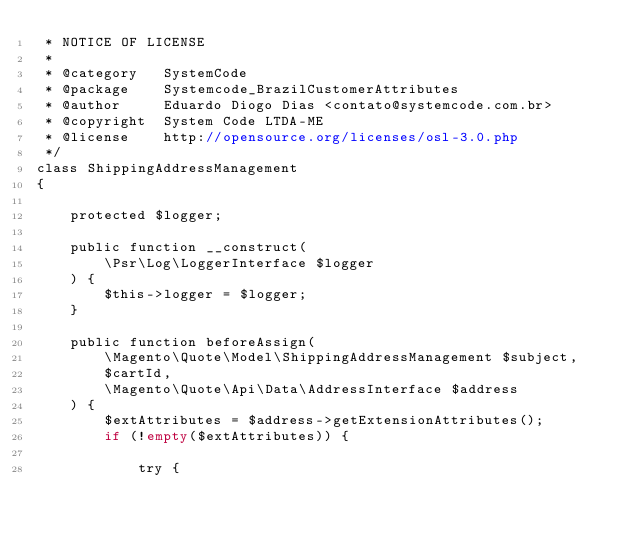<code> <loc_0><loc_0><loc_500><loc_500><_PHP_> * NOTICE OF LICENSE
 *
 * @category   SystemCode
 * @package    Systemcode_BrazilCustomerAttributes
 * @author     Eduardo Diogo Dias <contato@systemcode.com.br>
 * @copyright  System Code LTDA-ME
 * @license    http://opensource.org/licenses/osl-3.0.php
 */
class ShippingAddressManagement
{

    protected $logger;

    public function __construct(
        \Psr\Log\LoggerInterface $logger
    ) {
        $this->logger = $logger;
    }

    public function beforeAssign(
        \Magento\Quote\Model\ShippingAddressManagement $subject,
        $cartId,
        \Magento\Quote\Api\Data\AddressInterface $address
    ) {
        $extAttributes = $address->getExtensionAttributes();
        if (!empty($extAttributes)) {

            try {</code> 